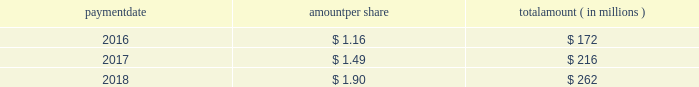Humana inc .
Notes to consolidated financial statements 2014 ( continued ) 15 .
Stockholders 2019 equity dividends the table provides details of dividend payments , excluding dividend equivalent rights , in 2016 , 2017 , and 2018 under our board approved quarterly cash dividend policy : payment amount per share amount ( in millions ) .
On november 2 , 2018 , the board declared a cash dividend of $ 0.50 per share that was paid on january 25 , 2019 to stockholders of record on december 31 , 2018 , for an aggregate amount of $ 68 million .
Declaration and payment of future quarterly dividends is at the discretion of our board and may be adjusted as business needs or market conditions change .
In february 2019 , the board declared a cash dividend of $ 0.55 per share payable on april 26 , 2019 to stockholders of record on march 29 , 2019 .
Stock repurchases our board of directors may authorize the purchase of our common shares .
Under our share repurchase authorization , shares may have been purchased from time to time at prevailing prices in the open market , by block purchases , through plans designed to comply with rule 10b5-1 under the securities exchange act of 1934 , as amended , or in privately-negotiated transactions ( including pursuant to accelerated share repurchase agreements with investment banks ) , subject to certain regulatory restrictions on volume , pricing , and timing .
On february 14 , 2017 , our board of directors authorized the repurchase of up to $ 2.25 billion of our common shares expiring on december 31 , 2017 , exclusive of shares repurchased in connection with employee stock plans .
On february 16 , 2017 , we entered into an accelerated share repurchase agreement , the february 2017 asr , with goldman , sachs & co .
Llc , or goldman sachs , to repurchase $ 1.5 billion of our common stock as part of the $ 2.25 billion share repurchase authorized on february 14 , 2017 .
On february 22 , 2017 , we made a payment of $ 1.5 billion to goldman sachs from available cash on hand and received an initial delivery of 5.83 million shares of our common stock from goldman sachs based on the then current market price of humana common stock .
The payment to goldman sachs was recorded as a reduction to stockholders 2019 equity , consisting of a $ 1.2 billion increase in treasury stock , which reflected the value of the initial 5.83 million shares received upon initial settlement , and a $ 300 million decrease in capital in excess of par value , which reflected the value of stock held back by goldman sachs pending final settlement of the february 2017 asr .
Upon settlement of the february 2017 asr on august 28 , 2017 , we received an additional 0.84 million shares as determined by the average daily volume weighted-average share price of our common stock during the term of the agreement of $ 224.81 , less a discount and subject to adjustments pursuant to the terms and conditions of the february 2017 asr , bringing the total shares received under this program to 6.67 million .
In addition , upon settlement we reclassified the $ 300 million value of stock initially held back by goldman sachs from capital in excess of par value to treasury stock .
Subsequent to settlement of the february 2017 asr , we repurchased an additional 3.04 million shares in the open market , utilizing the remaining $ 750 million of the $ 2.25 billion authorization prior to expiration .
On december 14 , 2017 , our board of directors authorized the repurchase of up to $ 3.0 billion of our common shares expiring on december 31 , 2020 , exclusive of shares repurchased in connection with employee stock plans. .
Considering the years 2017-2018 , what is the increase observed in payment amount per share? 
Rationale: it is the amount paid per share in 2018 divided by the 2017's , then transformed into a percentage to represent the increase .
Computations: ((1.90 / 1.49) - 1)
Answer: 0.27517. 